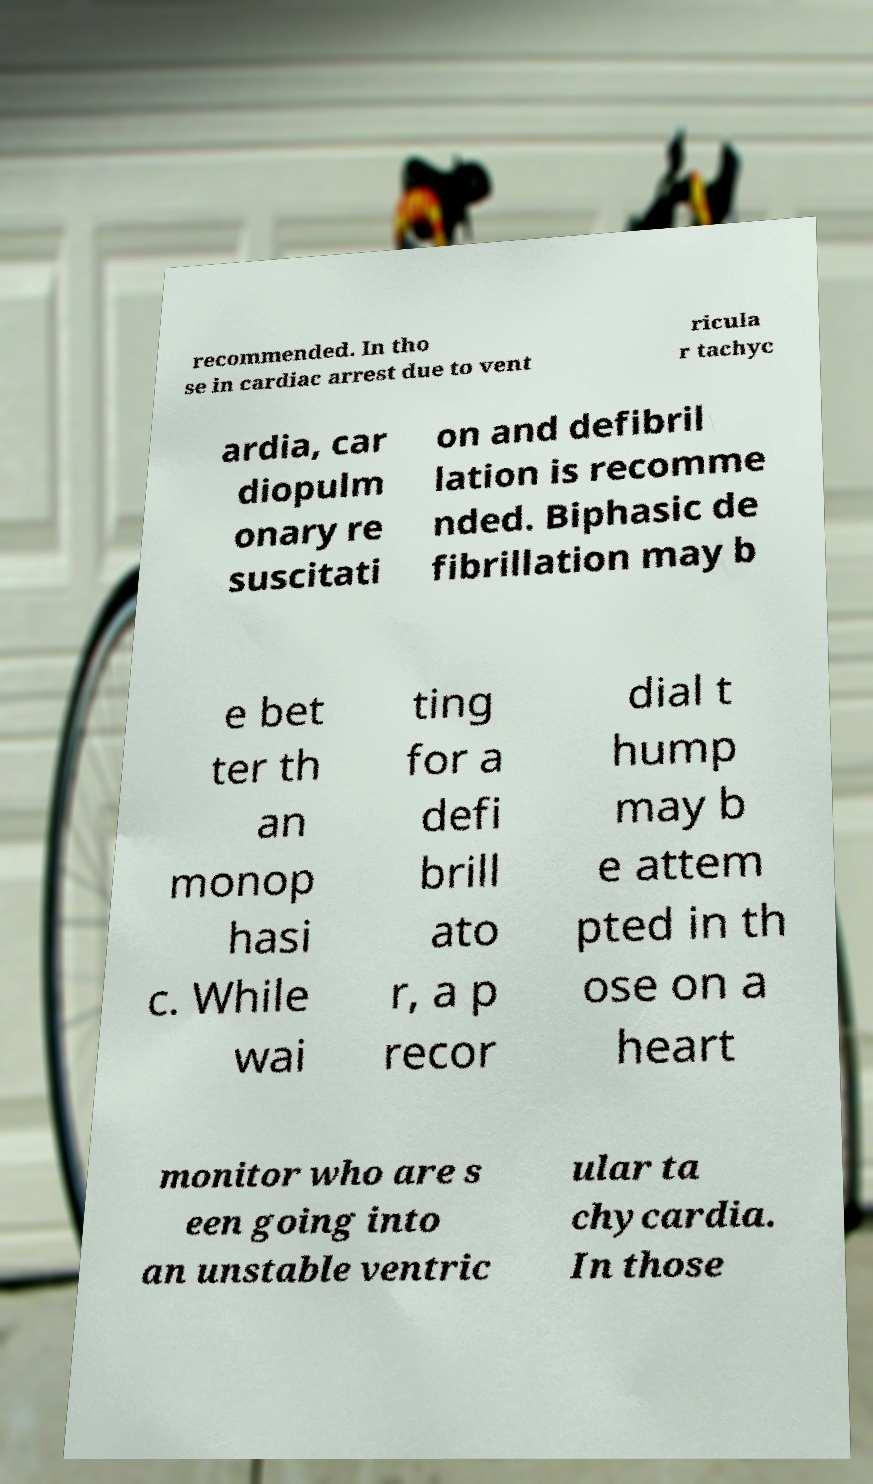There's text embedded in this image that I need extracted. Can you transcribe it verbatim? recommended. In tho se in cardiac arrest due to vent ricula r tachyc ardia, car diopulm onary re suscitati on and defibril lation is recomme nded. Biphasic de fibrillation may b e bet ter th an monop hasi c. While wai ting for a defi brill ato r, a p recor dial t hump may b e attem pted in th ose on a heart monitor who are s een going into an unstable ventric ular ta chycardia. In those 